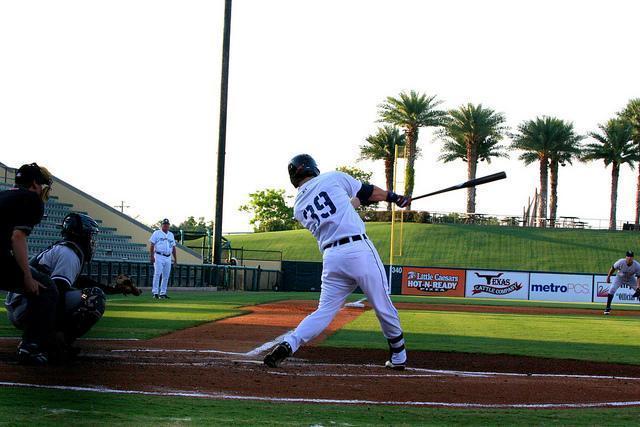How many shirts hanging?
Give a very brief answer. 0. How many people are sitting on the benches?
Give a very brief answer. 0. How many people are visible?
Give a very brief answer. 3. 